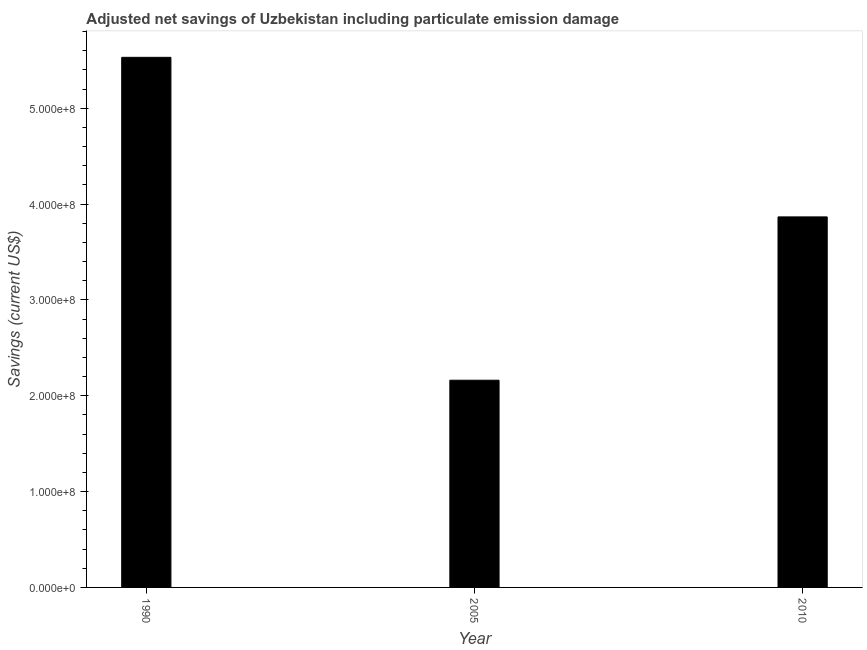Does the graph contain any zero values?
Your answer should be very brief. No. What is the title of the graph?
Provide a short and direct response. Adjusted net savings of Uzbekistan including particulate emission damage. What is the label or title of the Y-axis?
Offer a very short reply. Savings (current US$). What is the adjusted net savings in 2005?
Offer a very short reply. 2.16e+08. Across all years, what is the maximum adjusted net savings?
Offer a very short reply. 5.53e+08. Across all years, what is the minimum adjusted net savings?
Your answer should be compact. 2.16e+08. In which year was the adjusted net savings minimum?
Offer a very short reply. 2005. What is the sum of the adjusted net savings?
Your answer should be very brief. 1.16e+09. What is the difference between the adjusted net savings in 2005 and 2010?
Ensure brevity in your answer.  -1.70e+08. What is the average adjusted net savings per year?
Ensure brevity in your answer.  3.85e+08. What is the median adjusted net savings?
Provide a succinct answer. 3.87e+08. In how many years, is the adjusted net savings greater than 200000000 US$?
Provide a short and direct response. 3. Do a majority of the years between 1990 and 2005 (inclusive) have adjusted net savings greater than 120000000 US$?
Offer a terse response. Yes. What is the ratio of the adjusted net savings in 1990 to that in 2005?
Offer a very short reply. 2.56. Is the adjusted net savings in 2005 less than that in 2010?
Provide a short and direct response. Yes. What is the difference between the highest and the second highest adjusted net savings?
Your answer should be very brief. 1.66e+08. Is the sum of the adjusted net savings in 1990 and 2010 greater than the maximum adjusted net savings across all years?
Ensure brevity in your answer.  Yes. What is the difference between the highest and the lowest adjusted net savings?
Ensure brevity in your answer.  3.37e+08. How many bars are there?
Ensure brevity in your answer.  3. Are all the bars in the graph horizontal?
Offer a very short reply. No. Are the values on the major ticks of Y-axis written in scientific E-notation?
Keep it short and to the point. Yes. What is the Savings (current US$) of 1990?
Offer a terse response. 5.53e+08. What is the Savings (current US$) in 2005?
Provide a succinct answer. 2.16e+08. What is the Savings (current US$) in 2010?
Offer a very short reply. 3.87e+08. What is the difference between the Savings (current US$) in 1990 and 2005?
Offer a terse response. 3.37e+08. What is the difference between the Savings (current US$) in 1990 and 2010?
Ensure brevity in your answer.  1.66e+08. What is the difference between the Savings (current US$) in 2005 and 2010?
Make the answer very short. -1.70e+08. What is the ratio of the Savings (current US$) in 1990 to that in 2005?
Offer a terse response. 2.56. What is the ratio of the Savings (current US$) in 1990 to that in 2010?
Your answer should be very brief. 1.43. What is the ratio of the Savings (current US$) in 2005 to that in 2010?
Your answer should be very brief. 0.56. 